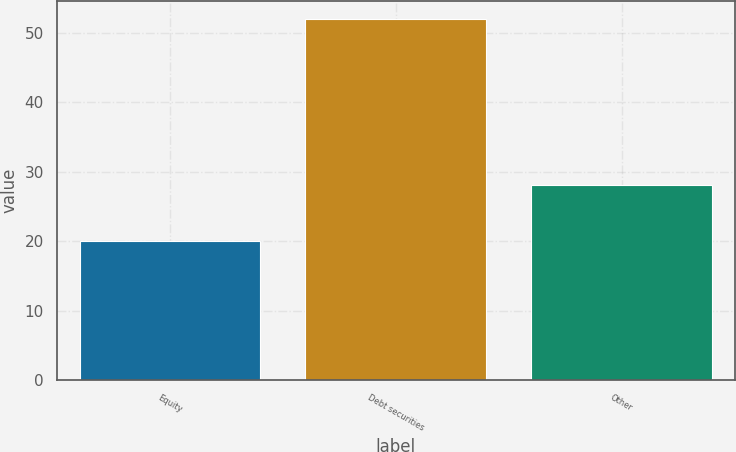<chart> <loc_0><loc_0><loc_500><loc_500><bar_chart><fcel>Equity<fcel>Debt securities<fcel>Other<nl><fcel>20<fcel>52<fcel>28<nl></chart> 